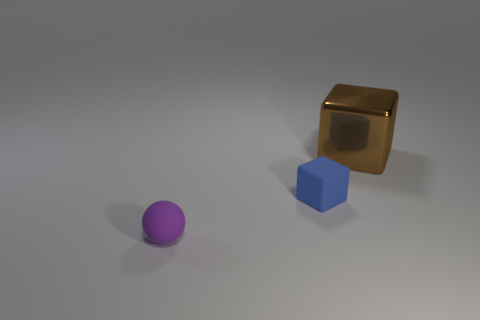Is the number of rubber spheres that are behind the big brown shiny thing greater than the number of objects behind the matte sphere?
Ensure brevity in your answer.  No. There is a small matte thing on the left side of the small block; what is its color?
Your answer should be very brief. Purple. Are there any brown shiny things that have the same shape as the purple object?
Provide a short and direct response. No. What number of brown objects are small cubes or large blocks?
Provide a succinct answer. 1. Are there any brown shiny cubes of the same size as the purple rubber sphere?
Give a very brief answer. No. What number of small things are there?
Offer a terse response. 2. What number of large objects are blue rubber objects or cubes?
Your answer should be very brief. 1. There is a cube in front of the thing behind the block in front of the brown shiny block; what color is it?
Offer a very short reply. Blue. What number of other objects are the same color as the matte sphere?
Make the answer very short. 0. What number of metallic objects are either small gray cubes or tiny blue cubes?
Provide a short and direct response. 0. 